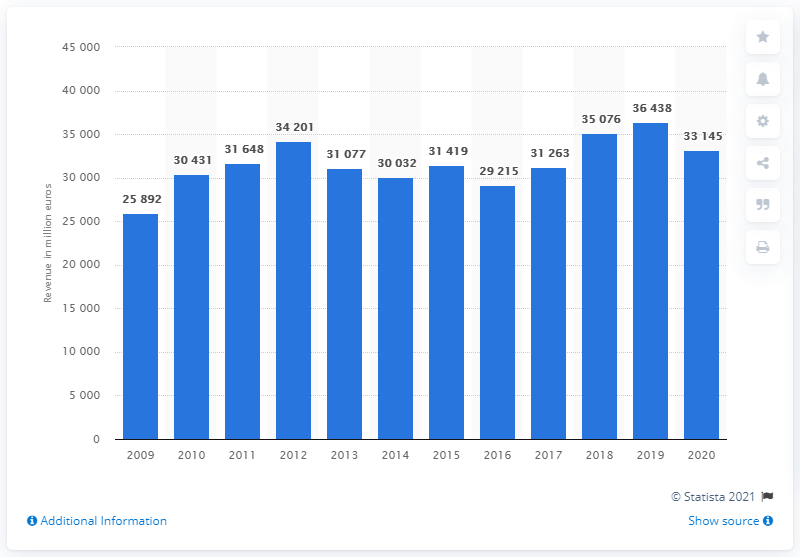Draw attention to some important aspects in this diagram. Iberdrola's revenues decreased by 33,145 in 2020. In 2020, Iberdrola generated a revenue of 331,450 units. 